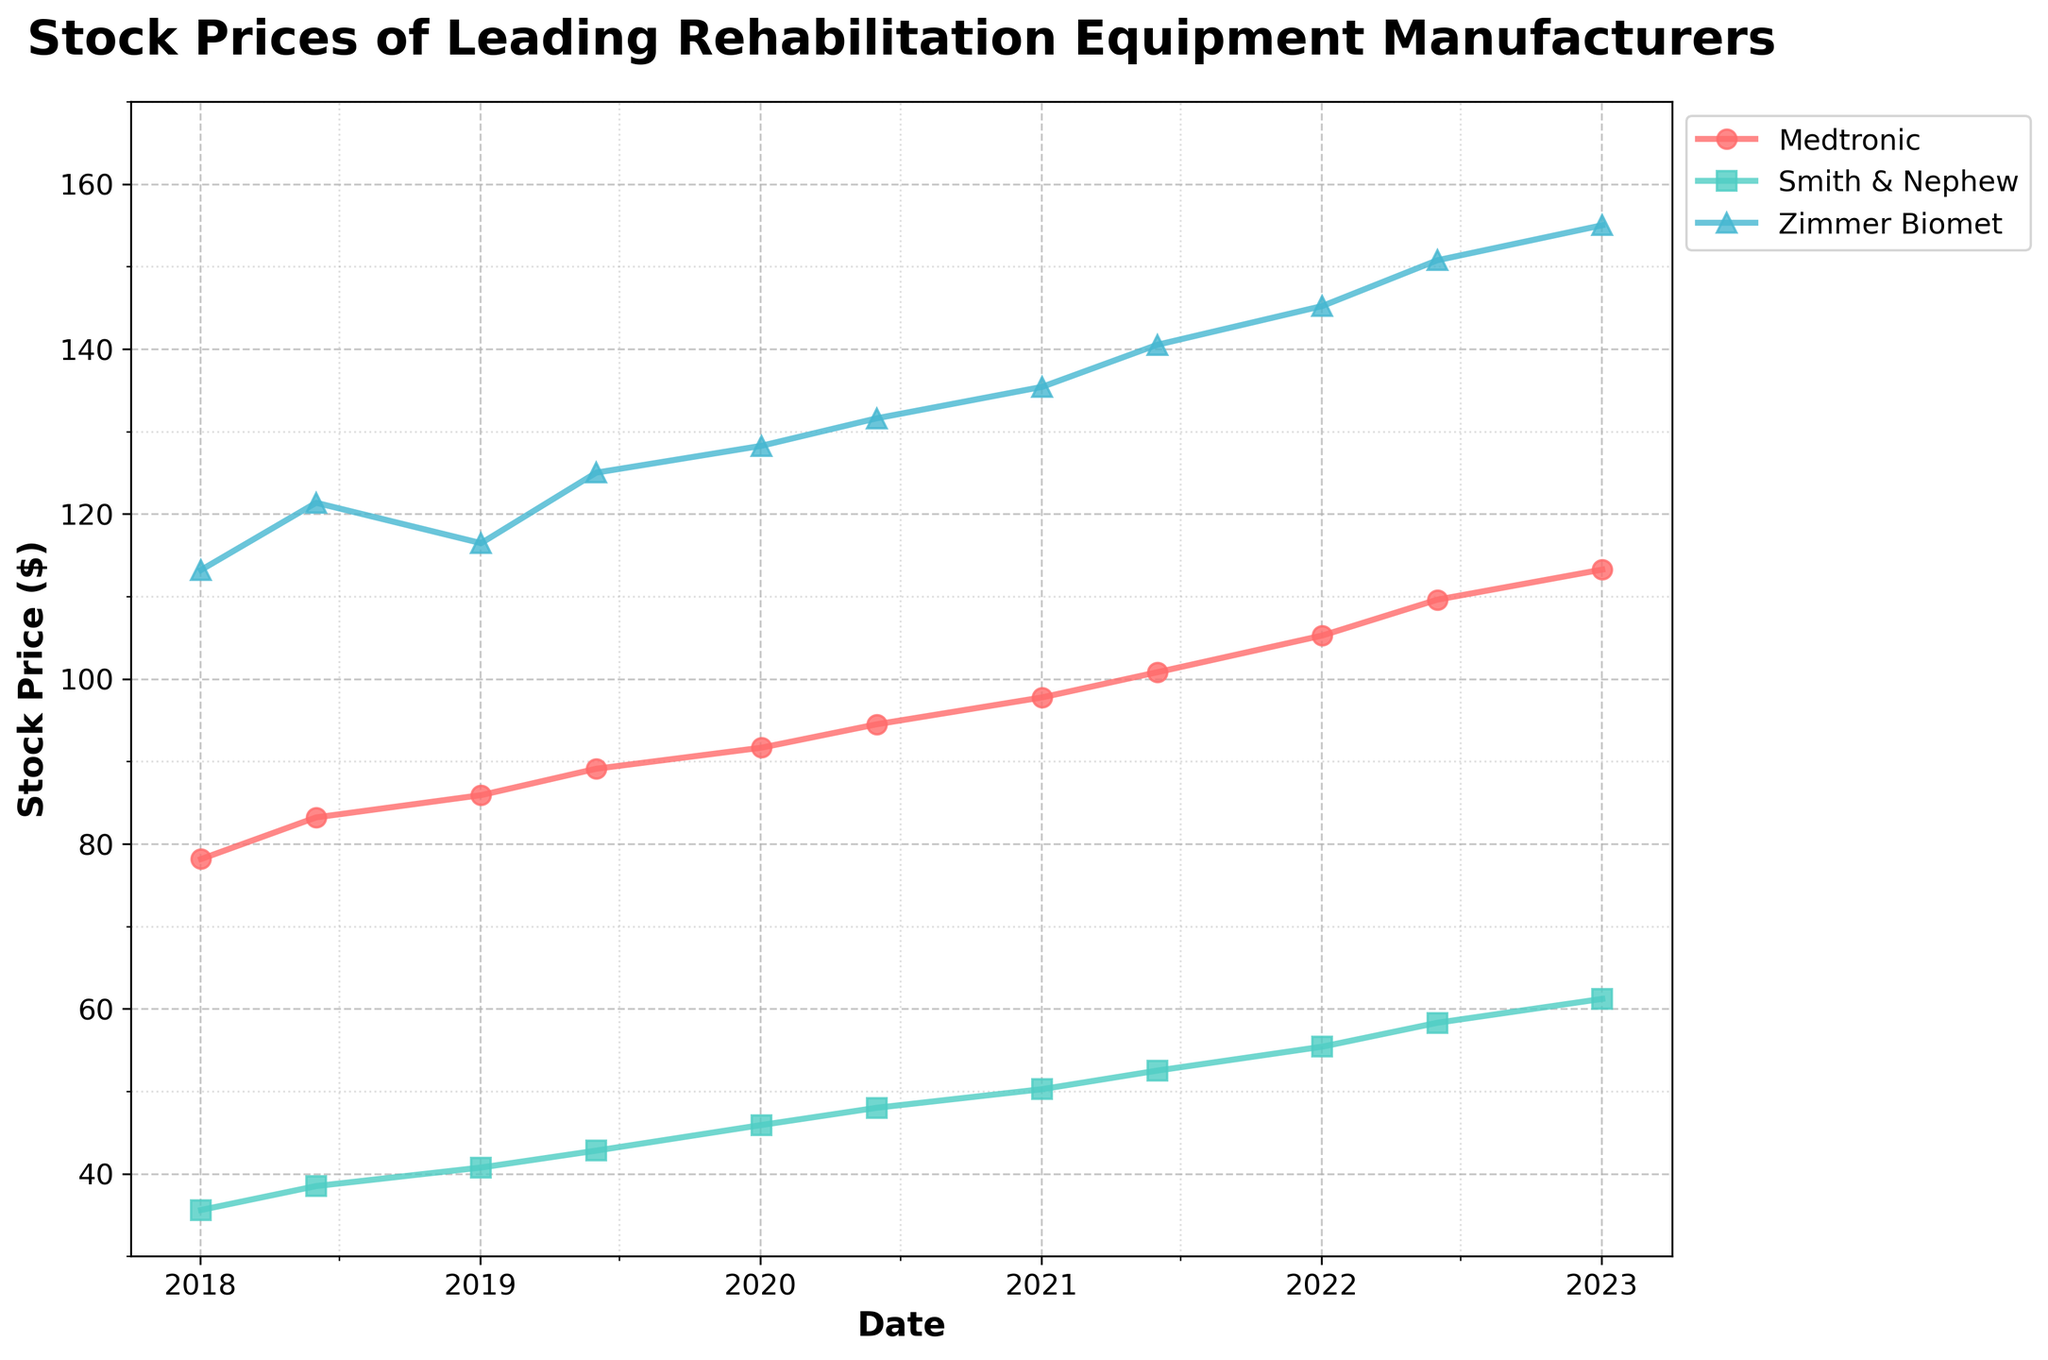What is the title of the figure? The title of the figure is placed at the top of the plot. By observing this, we can identify the exact wording used.
Answer: Stock Prices of Leading Rehabilitation Equipment Manufacturers How many companies are represented in the figure? By counting the unique labels in the legend, we can determine the number of distinct companies shown in the figure.
Answer: 3 Which company had the highest stock price on January 2, 2023? We look at the data points nearest to January 2, 2023, and compare the stock prices for each company.
Answer: Zimmer Biomet What was the stock price of Medtronic in June 2018? We refer to the data point for Medtronic closest to June 2018 and read the value on the y-axis.
Answer: 83.20 Did Smith & Nephew's stock price ever surpass $60 in the past 5 years? We scan through the trend line for Smith & Nephew and check if it crosses the $60 level.
Answer: Yes Which company shows the most significant increase in stock price over the 5 years? We calculate the difference between the final and initial stock prices for each company and compare the values.
Answer: Medtronic How did Zimmer Biomet's stock price trend from 2019 to 2020? By examining the plot, we can observe the changes in Zimmer Biomet's stock price between the given dates and note any upward or downward trends.
Answer: It increased Compare the stock price trends of Medtronic and Smith & Nephew from 2021 to 2023. By following the trend lines of Medtronic and Smith & Nephew between these years, we can determine their general movements and make comparisons.
Answer: Both increased steadily What is the average stock price of Smith & Nephew across the plotted dates? We sum up all the stock prices of Smith & Nephew and divide by the number of data points to find the average.
Answer: (35.60 + 38.50 + 40.75 + 42.80 + 45.90 + 48.00 + 50.25 + 52.50 + 55.40 + 58.30 + 61.20) / 11 = 48.04 